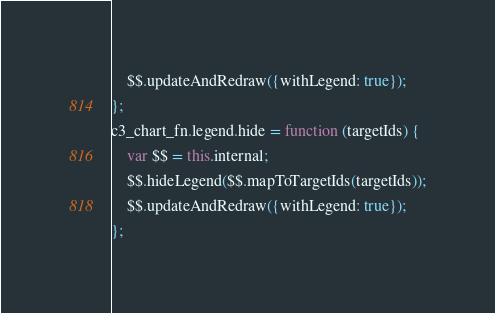<code> <loc_0><loc_0><loc_500><loc_500><_JavaScript_>    $$.updateAndRedraw({withLegend: true});
};
c3_chart_fn.legend.hide = function (targetIds) {
    var $$ = this.internal;
    $$.hideLegend($$.mapToTargetIds(targetIds));
    $$.updateAndRedraw({withLegend: true});
};
</code> 